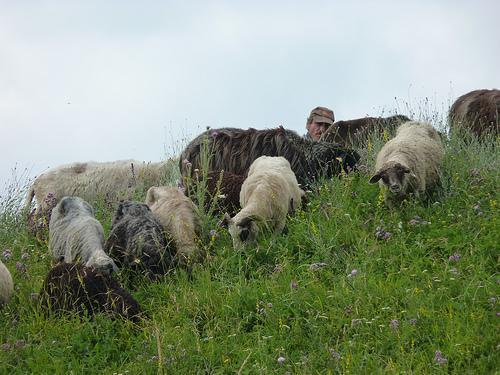How many people are in the picture?
Give a very brief answer. 1. 